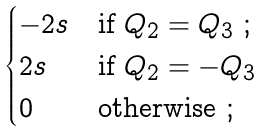<formula> <loc_0><loc_0><loc_500><loc_500>\begin{cases} - 2 s & \text {if } Q _ { 2 } = Q _ { 3 } \ ; \\ 2 s & \text {if } Q _ { 2 } = - Q _ { 3 } \\ 0 & \text {otherwise} \ ; \end{cases}</formula> 